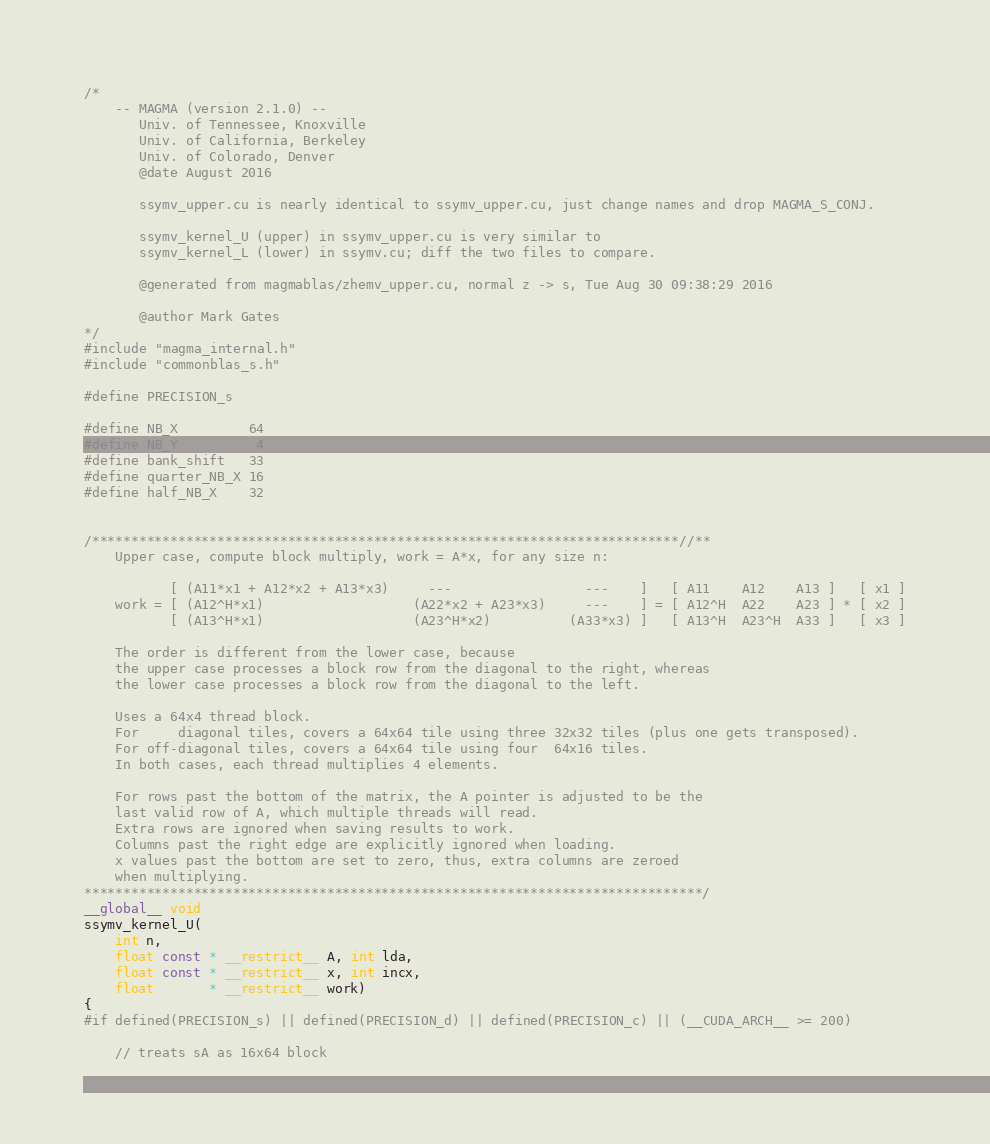<code> <loc_0><loc_0><loc_500><loc_500><_Cuda_>/*
    -- MAGMA (version 2.1.0) --
       Univ. of Tennessee, Knoxville
       Univ. of California, Berkeley
       Univ. of Colorado, Denver
       @date August 2016
       
       ssymv_upper.cu is nearly identical to ssymv_upper.cu, just change names and drop MAGMA_S_CONJ.
       
       ssymv_kernel_U (upper) in ssymv_upper.cu is very similar to
       ssymv_kernel_L (lower) in ssymv.cu; diff the two files to compare.
       
       @generated from magmablas/zhemv_upper.cu, normal z -> s, Tue Aug 30 09:38:29 2016
       
       @author Mark Gates
*/
#include "magma_internal.h"
#include "commonblas_s.h"

#define PRECISION_s

#define NB_X         64
#define NB_Y          4
#define bank_shift   33
#define quarter_NB_X 16
#define half_NB_X    32


/***************************************************************************//**
    Upper case, compute block multiply, work = A*x, for any size n:
    
           [ (A11*x1 + A12*x2 + A13*x3)     ---                 ---    ]   [ A11    A12    A13 ]   [ x1 ]
    work = [ (A12^H*x1)                   (A22*x2 + A23*x3)     ---    ] = [ A12^H  A22    A23 ] * [ x2 ]
           [ (A13^H*x1)                   (A23^H*x2)          (A33*x3) ]   [ A13^H  A23^H  A33 ]   [ x3 ]
    
    The order is different from the lower case, because
    the upper case processes a block row from the diagonal to the right, whereas
    the lower case processes a block row from the diagonal to the left.
    
    Uses a 64x4 thread block.
    For     diagonal tiles, covers a 64x64 tile using three 32x32 tiles (plus one gets transposed).
    For off-diagonal tiles, covers a 64x64 tile using four  64x16 tiles.
    In both cases, each thread multiplies 4 elements.
    
    For rows past the bottom of the matrix, the A pointer is adjusted to be the
    last valid row of A, which multiple threads will read.
    Extra rows are ignored when saving results to work.
    Columns past the right edge are explicitly ignored when loading.
    x values past the bottom are set to zero, thus, extra columns are zeroed
    when multiplying.
*******************************************************************************/
__global__ void
ssymv_kernel_U(
    int n,
    float const * __restrict__ A, int lda,
    float const * __restrict__ x, int incx,
    float       * __restrict__ work)
{
#if defined(PRECISION_s) || defined(PRECISION_d) || defined(PRECISION_c) || (__CUDA_ARCH__ >= 200)

    // treats sA as 16x64 block</code> 